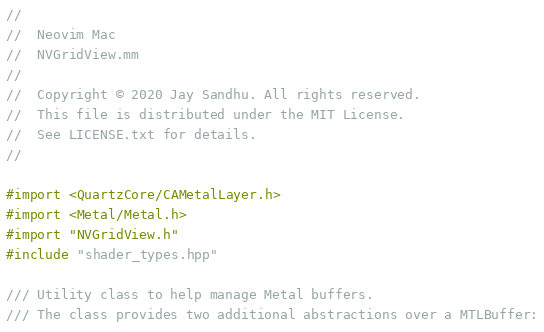Convert code to text. <code><loc_0><loc_0><loc_500><loc_500><_ObjectiveC_>//
//  Neovim Mac
//  NVGridView.mm
//
//  Copyright © 2020 Jay Sandhu. All rights reserved.
//  This file is distributed under the MIT License.
//  See LICENSE.txt for details.
//

#import <QuartzCore/CAMetalLayer.h>
#import <Metal/Metal.h>
#import "NVGridView.h"
#include "shader_types.hpp"

/// Utility class to help manage Metal buffers.
/// The class provides two additional abstractions over a MTLBuffer:</code> 